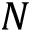Convert formula to latex. <formula><loc_0><loc_0><loc_500><loc_500>N</formula> 